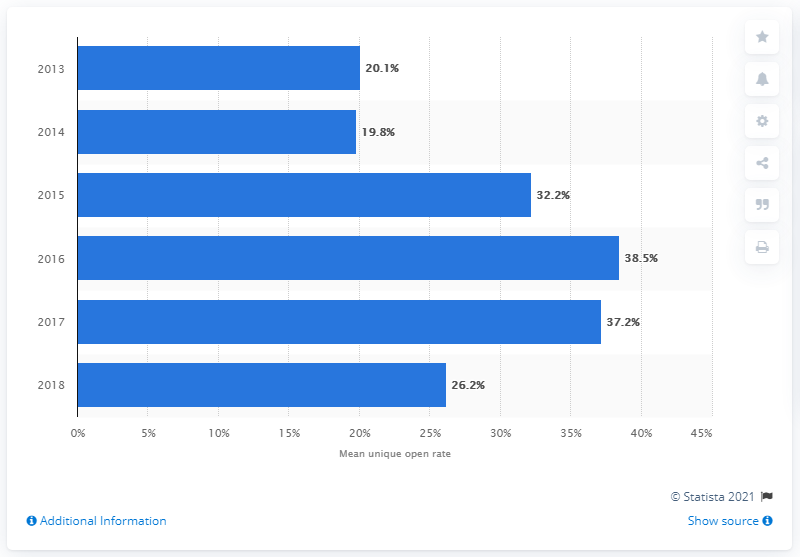Indicate a few pertinent items in this graphic. In the year 2016, the graph shows the highest data point. According to a study conducted in 2018, approximately 26.2% of promotional e-mails were opened in Canada. The average of the two lowest data points is 19.95. 